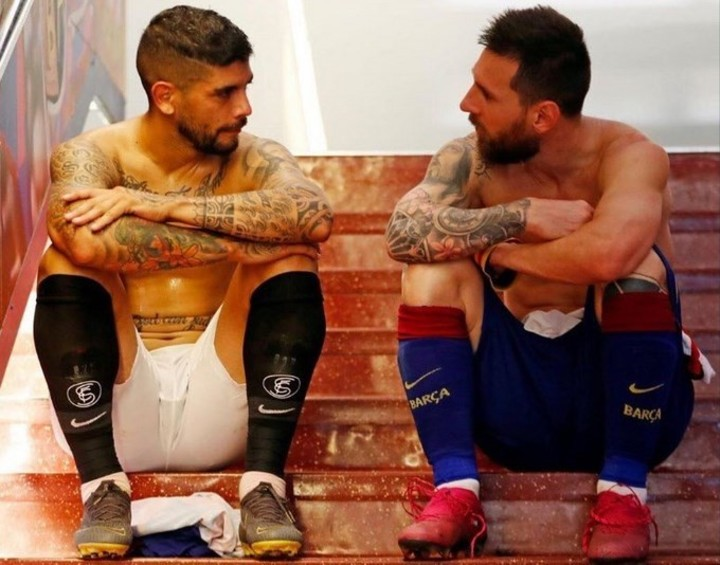What could they be discussing in such a setting? In a setting like this, the players could be discussing a recent game, focusing on strategies, tactics, and individual performances. They might be reflecting on key moments of the match, analyzing what went well and what could have been done differently. It is also possible that they are discussing upcoming matches, formulating plans, and sharing insights to improve their teamwork and performance. The setting suggests a candid and thoughtful exchange, emphasizing the importance of their conversation to their sporting journey. Why might they have chosen this place for their conversation? The players might have chosen this place for its privacy and seclusion. The stairway provides a quiet space away from the hustle and bustle of the locker room or the field, allowing for a more personal and undisturbed conversation. It’s a spot where they can speak freely and openly, without distractions, making it ideal for discussing sensitive or important topics. The informal setting might also help them feel more relaxed and able to communicate their thoughts and feelings honestly. How does the atmosphere contribute to their conversation? The atmosphere of the stairway, with its calm and isolated environment, contributes significantly to the nature of their conversation. It allows for a sense of intimacy and confidentiality, enabling the players to express their thoughts without fear of interruption or judgment. The setting likely encourages a more heartfelt and genuine dialogue, fostering a deeper connection and understanding between the two. The quiet and straightforward surroundings also help them focus solely on each other and the topic at hand, making the conversation more meaningful and impactful. If this conversation was turned into a motivational speech, what might be the key message? If this conversation was turned into a motivational speech, the key message might revolve around the themes of resilience, teamwork, and continuous improvement. It could emphasize the importance of learning from every experience, both successes and failures, and using those lessons to grow stronger and more determined. The speech might highlight the value of honest communication and support among teammates, stressing that through mutual understanding and shared goals, they can overcome any challenge. Ultimately, the core message would be about staying focused, staying united, and always striving to be better, both individually and as a team. 